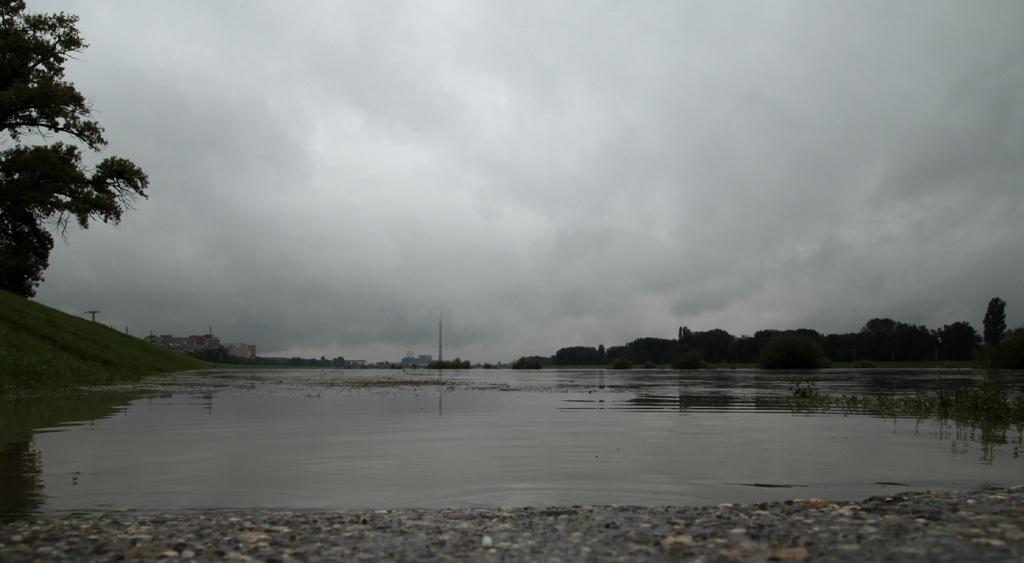What type of natural elements can be seen in the image? There are stones, water, trees, and grass visible in the image. What type of structures are present in the image? There are buildings and poles visible in the image. What is visible in the background of the image? The sky is visible in the background of the image. What can be seen in the sky? Clouds are present in the sky. What type of disease is affecting the trees in the image? There is no indication of any disease affecting the trees in the image; they appear healthy. How many birds are visible in the image? There are no birds present in the image. 